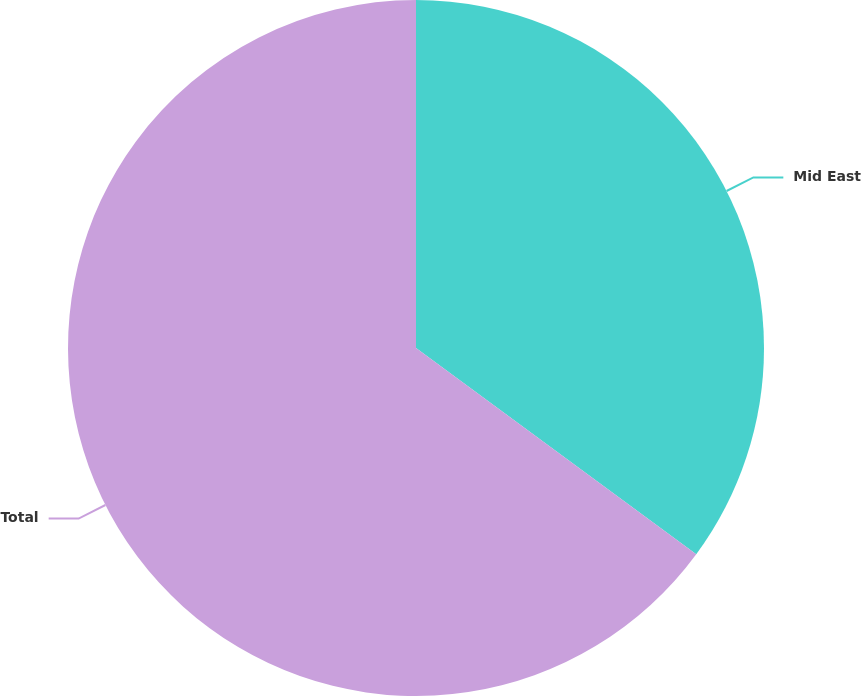Convert chart. <chart><loc_0><loc_0><loc_500><loc_500><pie_chart><fcel>Mid East<fcel>Total<nl><fcel>35.1%<fcel>64.9%<nl></chart> 